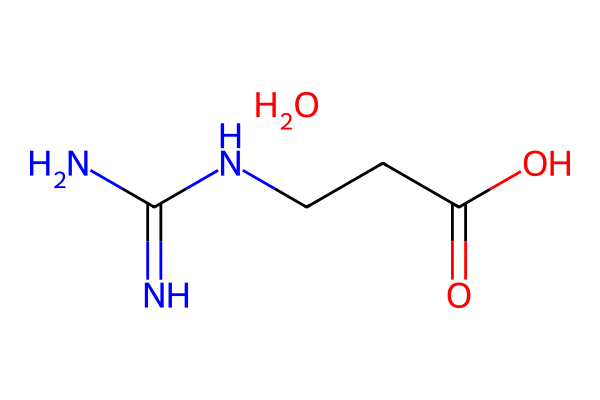What is the molecular formula of creatine monohydrate? The SMILES representation shows key components of the molecule. The nitrogen (N) and carbon (C) atoms combine to form the backbone, while the oxygen (O) from the carboxyl group indicates that there is a water molecule present (indicated by the ".O"). Counting the elements gives the molecular formula C4H9N3O2.
Answer: C4H9N3O2 How many nitrogen atoms are present in the structure? By examining the SMILES string, we note there are three instances of nitrogen (N) indicated in the formula. This count can be visually confirmed by looking for every "N" in the structure.
Answer: 3 What is the functional group present in creatine monohydrate that indicates it is a carboxylic acid? The presence of a -COOH (carboxyl) group can be identified from the section "C(=O)O" in the SMILES notation. The "=" indicates a double bond to Oxygen, typical of carboxylic acids.
Answer: carboxylic acid Does creatine monohydrate contain any hydroxyl groups? The presence of an -OH group indicates a hydroxyl; however, in this structure, there are no hydroxyl groups because there is no standalone -OH representation. The molecule has a -COOH group instead.
Answer: no What role does creatine monohydrate play in muscle growth? Creatine monohydrate enhances ATP production during exercise, facilitating energy delivery to muscle cells for longer periods. The nitrogen atoms indicate its nature as an amine, aiding in energy metabolism.
Answer: ATP production What is the primary source of the nitrogen atoms in creatine monohydrate? The nitrogen atoms come from the structure of the guanidine group present in creatine. The "NC(=N)N" segment indicates the guanidine structure which contains nitrogen.
Answer: guanidine group 